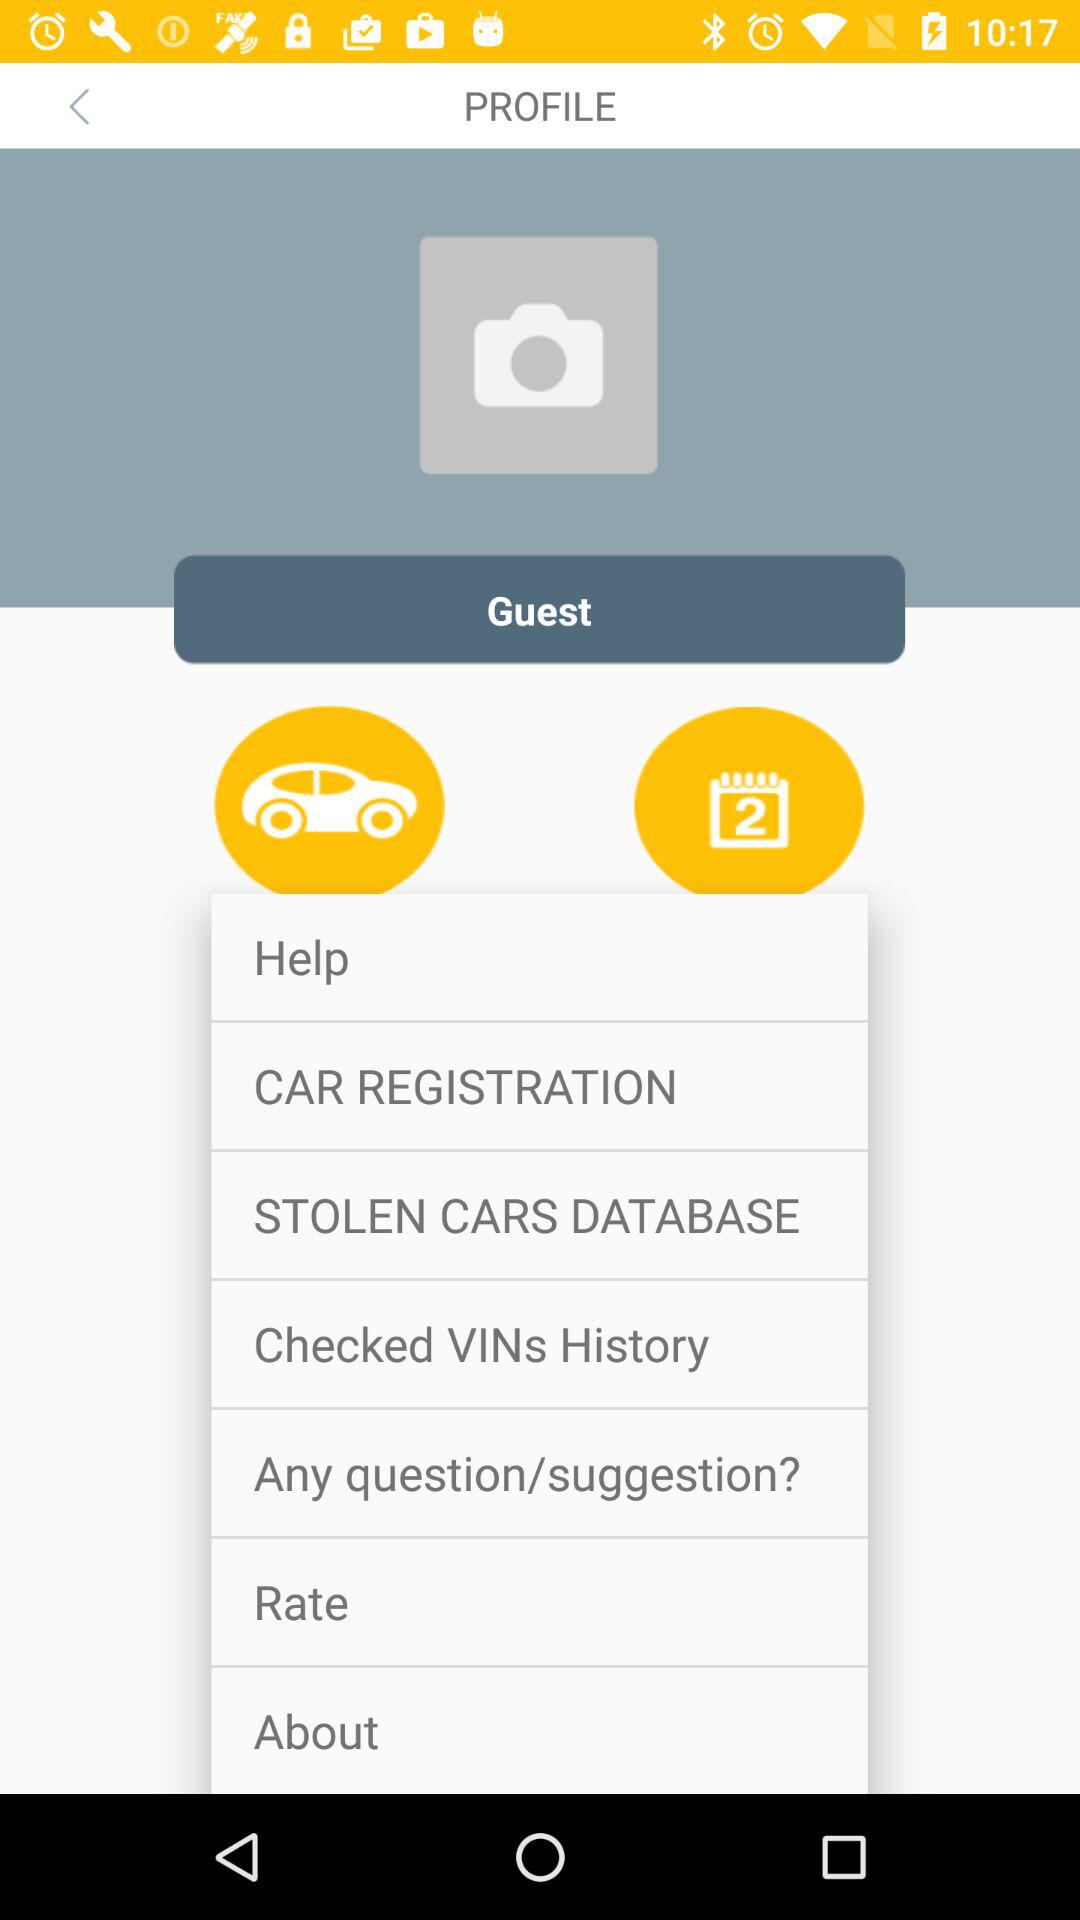Which date is mentioned?
When the provided information is insufficient, respond with <no answer>. <no answer> 